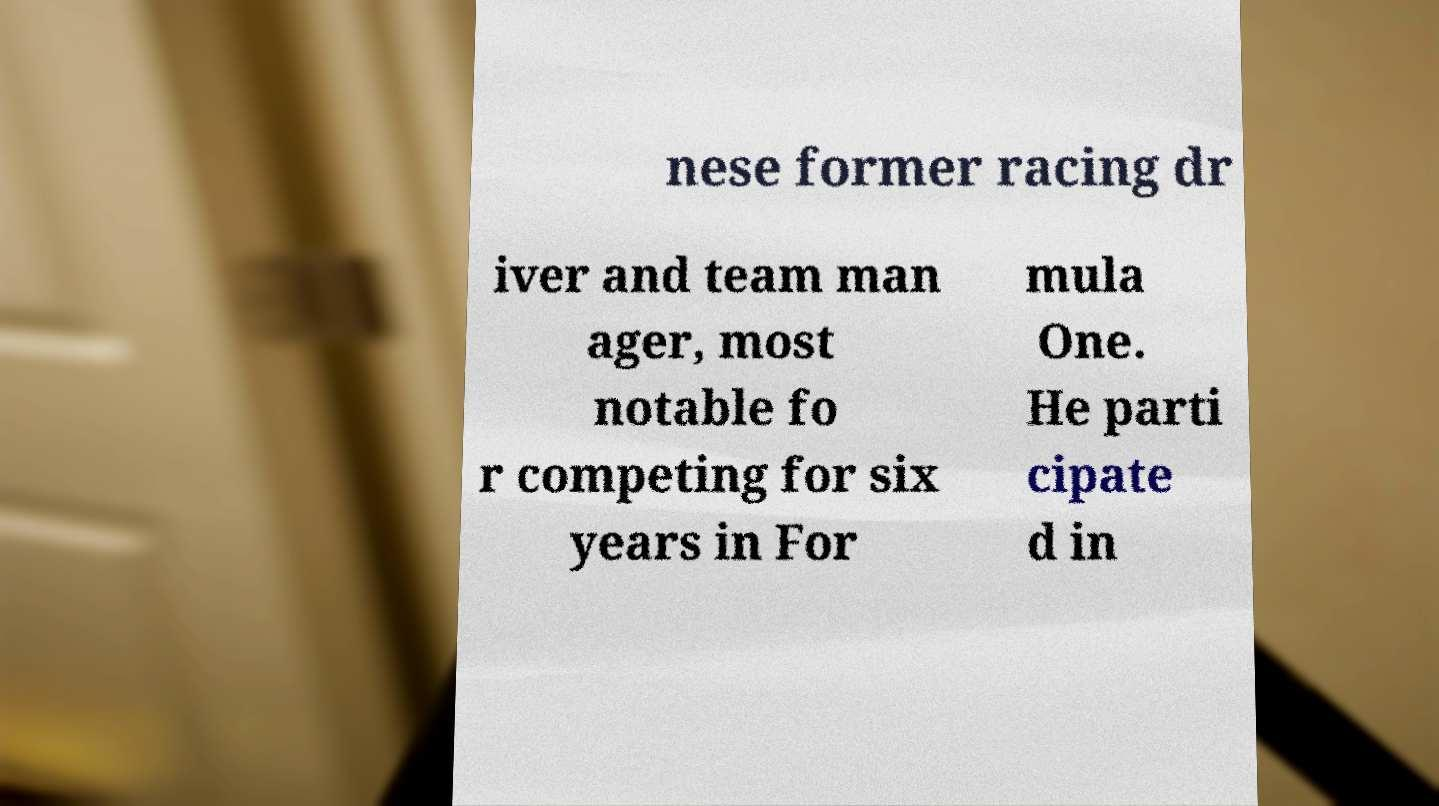Can you accurately transcribe the text from the provided image for me? nese former racing dr iver and team man ager, most notable fo r competing for six years in For mula One. He parti cipate d in 